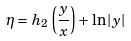<formula> <loc_0><loc_0><loc_500><loc_500>\eta = h _ { 2 } \left ( \frac { y } { x } \right ) + \ln | y |</formula> 